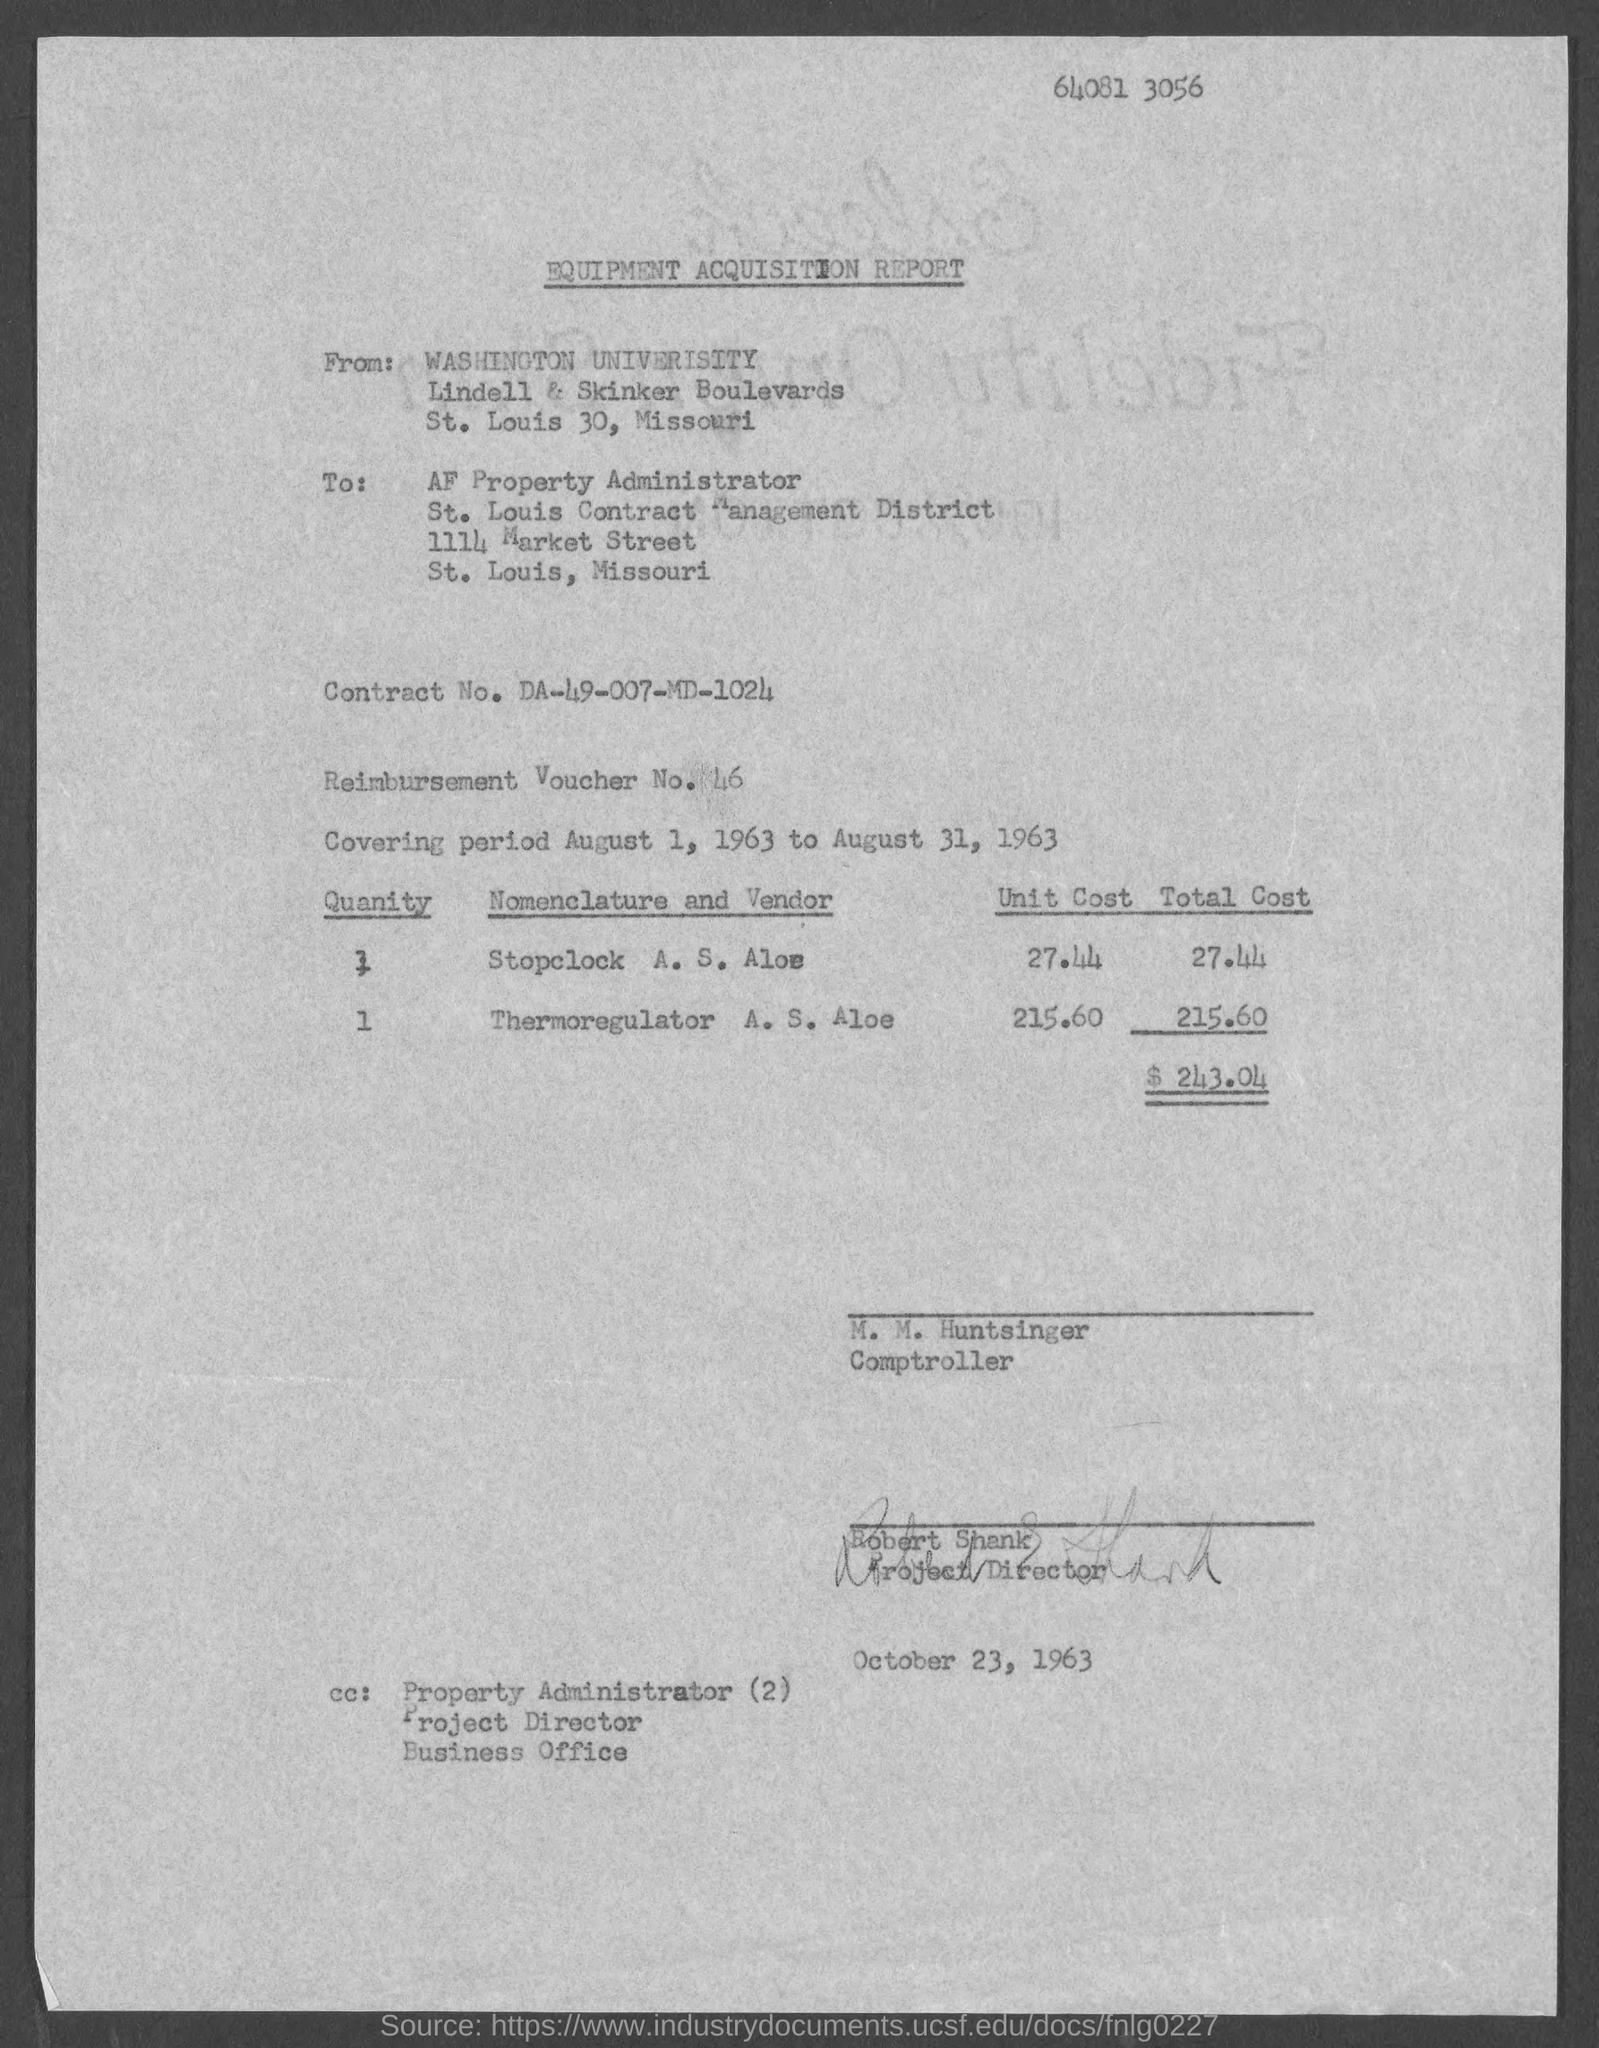List a handful of essential elements in this visual. The Equipment Acquisition Report does not mention a specific contract number. The contract number mentioned in the report is DA-49-007-MD-1024. The unit cost for the Thermoregulator, as stated in the Equipment Acquisition Report, is 215.60. The covering period referred to in the Equipment Acquisition Report is August 1, 1963 to August 31, 1963. The equipment acquisition report includes a reimbursement voucher number, which is 46. The unit cost for Stoplock, as stated in the Equipment Acquisition Report, is $27.44. 